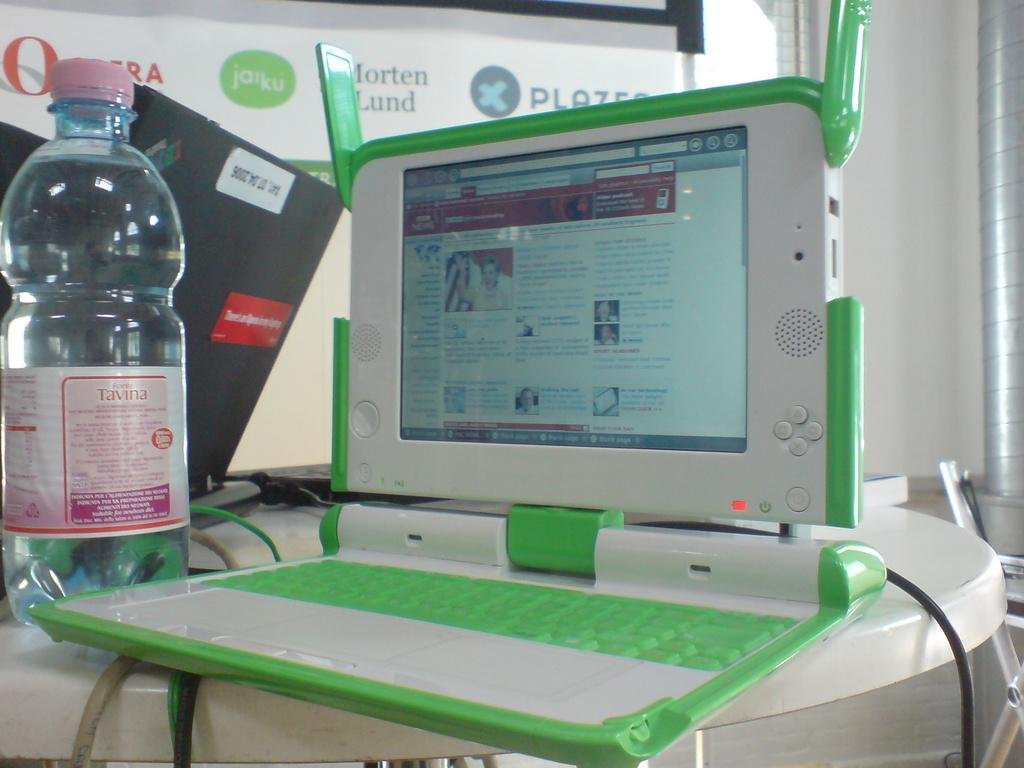Provide a one-sentence caption for the provided image. A table with an open laptop and a bottle of Tavina. 